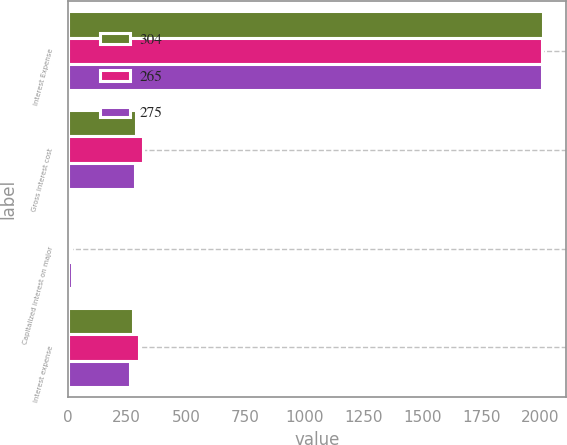<chart> <loc_0><loc_0><loc_500><loc_500><stacked_bar_chart><ecel><fcel>Interest Expense<fcel>Gross interest cost<fcel>Capitalized interest on major<fcel>Interest expense<nl><fcel>304<fcel>2009<fcel>288<fcel>13<fcel>275<nl><fcel>265<fcel>2008<fcel>318<fcel>14<fcel>304<nl><fcel>275<fcel>2007<fcel>283<fcel>18<fcel>265<nl></chart> 